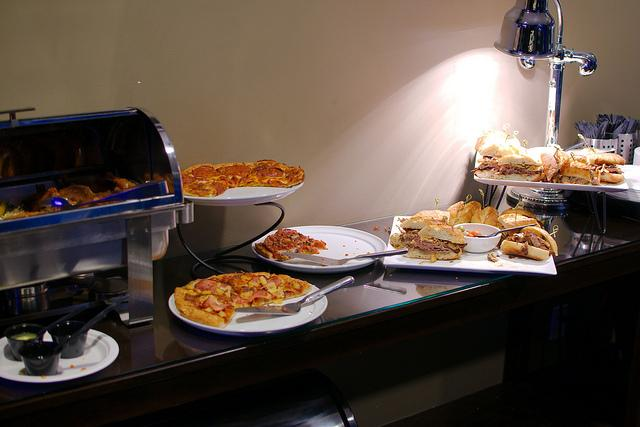What kind of service was this? Please explain your reasoning. catering. A table is filled with food in large serving dishes. caterers set food up on tables to serve people. 